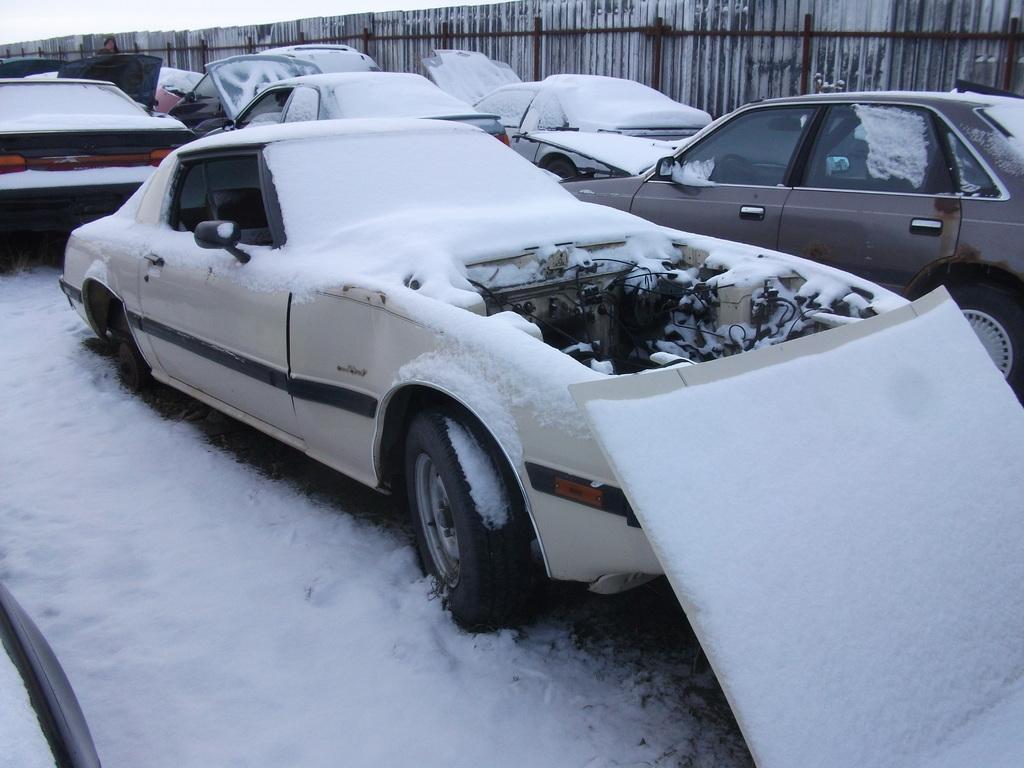Describe this image in one or two sentences. In the image we can see there are vehicles and some vehicles are covered with snow, and here we can see the fence. 